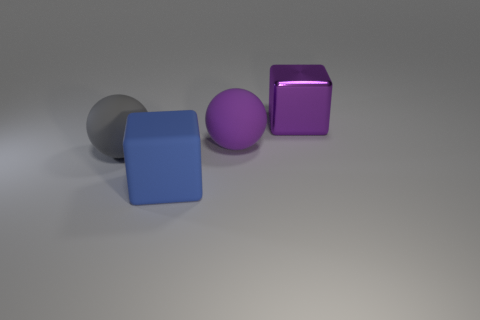Are there any other things that have the same material as the large purple block?
Provide a short and direct response. No. Are there more things behind the big metallic object than purple rubber blocks?
Give a very brief answer. No. Are there any gray spheres that are in front of the block that is on the left side of the block behind the big purple matte object?
Your answer should be very brief. No. Are there any blue matte objects behind the big blue block?
Your answer should be very brief. No. What number of large rubber objects have the same color as the metallic thing?
Your response must be concise. 1. What is the size of the gray sphere that is made of the same material as the blue object?
Your answer should be compact. Large. What is the size of the purple thing that is on the left side of the big cube behind the large rubber object in front of the large gray sphere?
Offer a very short reply. Large. There is a cube on the left side of the large purple sphere; what is its size?
Offer a very short reply. Large. How many gray things are either tiny shiny spheres or large matte balls?
Offer a terse response. 1. Are there any gray matte spheres that have the same size as the blue matte object?
Keep it short and to the point. Yes. 